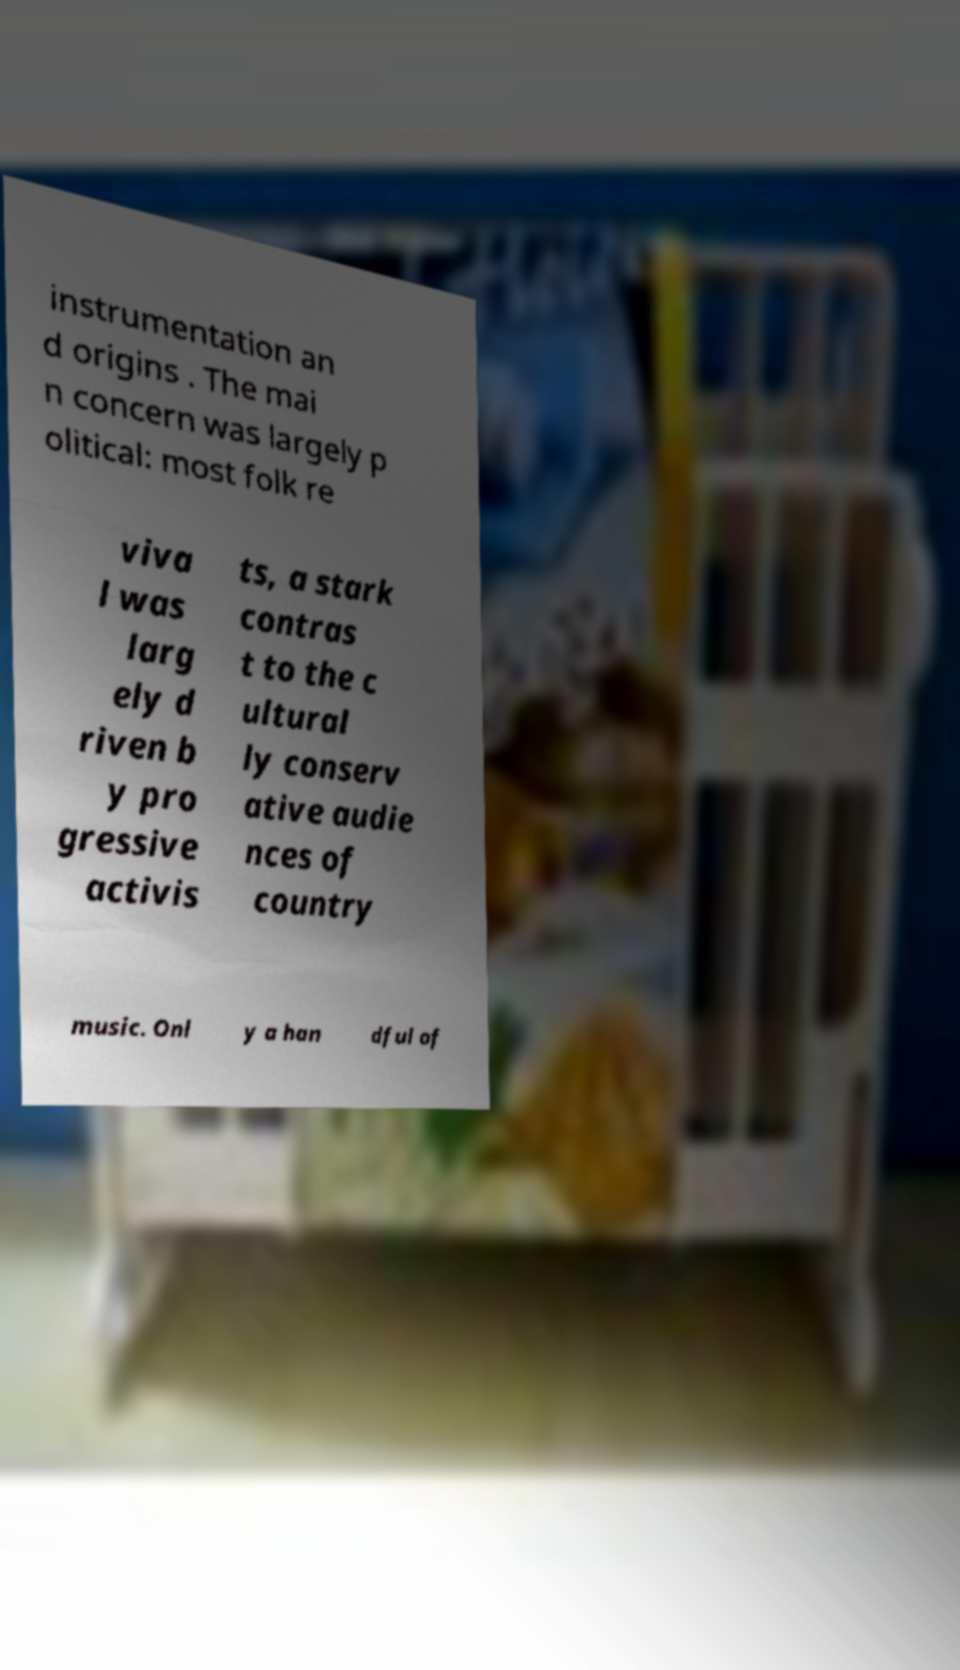I need the written content from this picture converted into text. Can you do that? instrumentation an d origins . The mai n concern was largely p olitical: most folk re viva l was larg ely d riven b y pro gressive activis ts, a stark contras t to the c ultural ly conserv ative audie nces of country music. Onl y a han dful of 